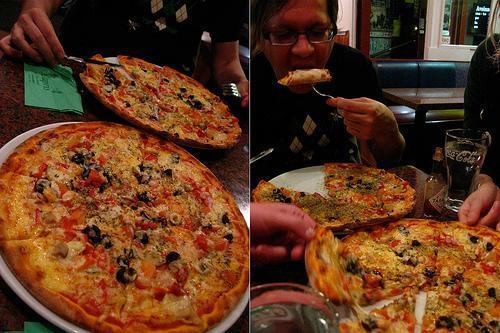How many pizzas are shown?
Give a very brief answer. 4. 